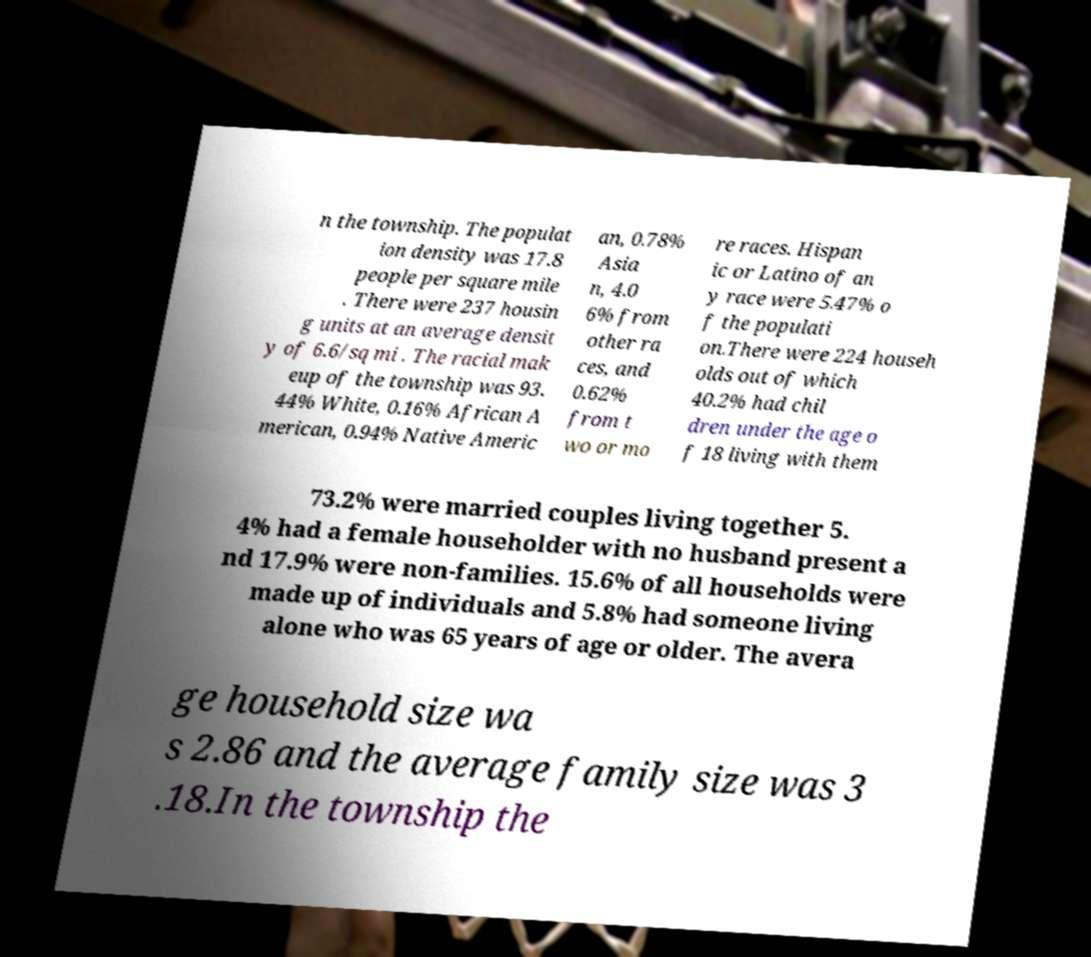What messages or text are displayed in this image? I need them in a readable, typed format. n the township. The populat ion density was 17.8 people per square mile . There were 237 housin g units at an average densit y of 6.6/sq mi . The racial mak eup of the township was 93. 44% White, 0.16% African A merican, 0.94% Native Americ an, 0.78% Asia n, 4.0 6% from other ra ces, and 0.62% from t wo or mo re races. Hispan ic or Latino of an y race were 5.47% o f the populati on.There were 224 househ olds out of which 40.2% had chil dren under the age o f 18 living with them 73.2% were married couples living together 5. 4% had a female householder with no husband present a nd 17.9% were non-families. 15.6% of all households were made up of individuals and 5.8% had someone living alone who was 65 years of age or older. The avera ge household size wa s 2.86 and the average family size was 3 .18.In the township the 